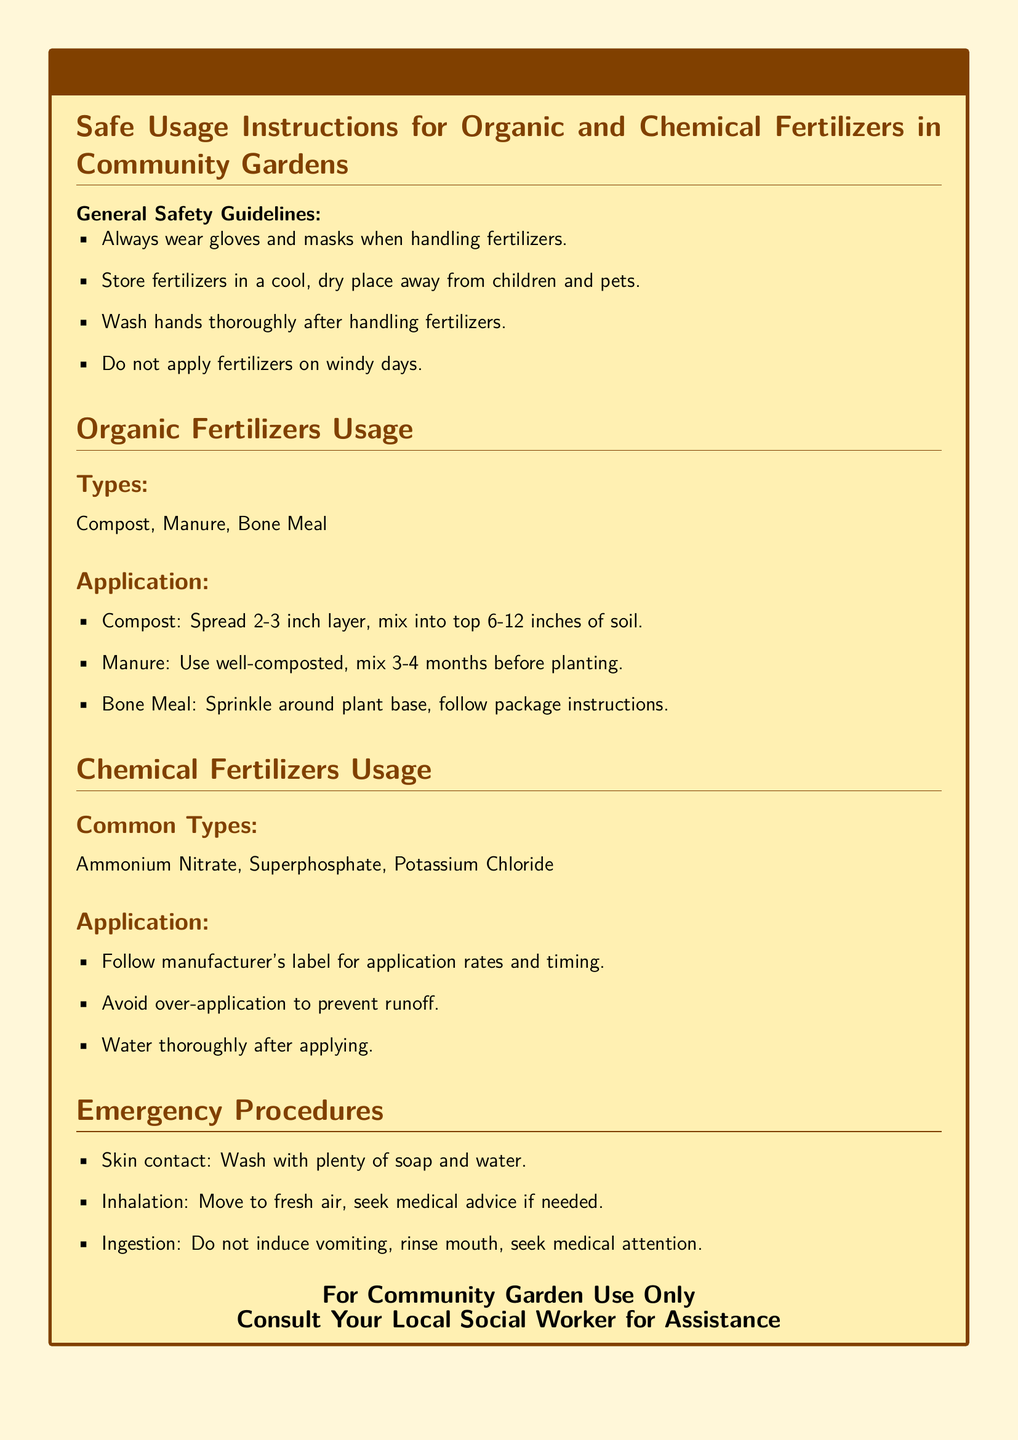What should you wear when handling fertilizers? The document states that you should always wear gloves and masks when handling fertilizers.
Answer: gloves and masks What is the recommended thickness for compost application? According to the document, you should spread a 2-3 inch layer of compost.
Answer: 2-3 inches What should you do after applying chemical fertilizers? The document advises to water thoroughly after applying chemical fertilizers.
Answer: water thoroughly What is the procedure for skin contact with fertilizers? The document instructs to wash with plenty of soap and water in case of skin contact.
Answer: wash with plenty of soap and water Which organic fertilizer should be well-composted? The document specifies that manure should be well-composted.
Answer: manure What is the common type of chemical fertilizer listed? The document lists Ammonium Nitrate as a common type of chemical fertilizer.
Answer: Ammonium Nitrate How deep should compost be mixed into the soil? According to the document, compost should be mixed into the top 6-12 inches of soil.
Answer: top 6-12 inches What should fertilizers be stored away from? The document indicates that fertilizers should be stored away from children and pets.
Answer: children and pets What is the title of the document? The title of the document is "Safe Usage Instructions for Organic and Chemical Fertilizers in Community Gardens."
Answer: Safe Usage Instructions for Organic and Chemical Fertilizers in Community Gardens 